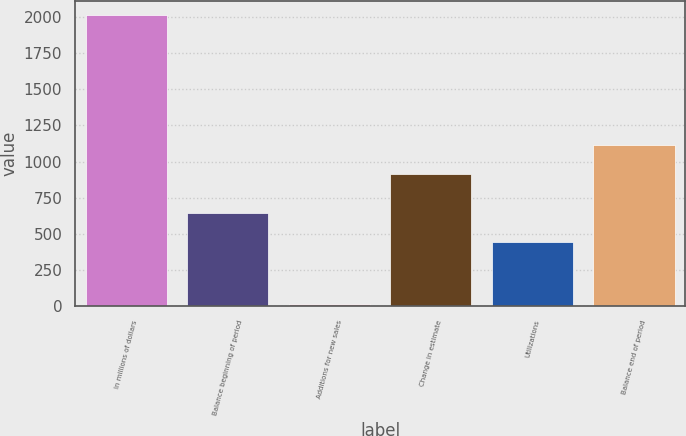<chart> <loc_0><loc_0><loc_500><loc_500><bar_chart><fcel>In millions of dollars<fcel>Balance beginning of period<fcel>Additions for new sales<fcel>Change in estimate<fcel>Utilizations<fcel>Balance end of period<nl><fcel>2010<fcel>645.4<fcel>16<fcel>917<fcel>446<fcel>1116.4<nl></chart> 